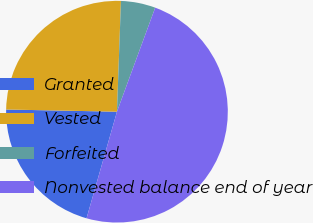Convert chart. <chart><loc_0><loc_0><loc_500><loc_500><pie_chart><fcel>Granted<fcel>Vested<fcel>Forfeited<fcel>Nonvested balance end of year<nl><fcel>20.89%<fcel>25.26%<fcel>5.03%<fcel>48.82%<nl></chart> 